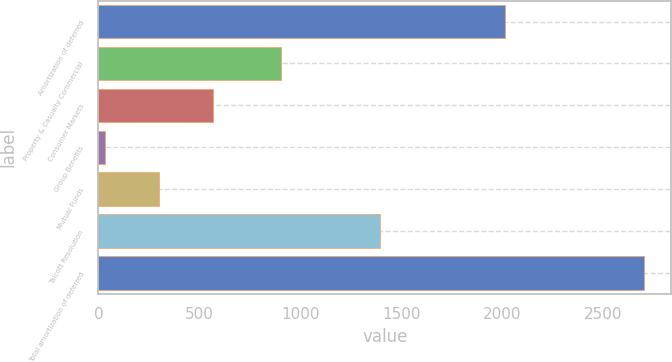Convert chart. <chart><loc_0><loc_0><loc_500><loc_500><bar_chart><fcel>Amortization of deferred<fcel>Property & Casualty Commercial<fcel>Consumer Markets<fcel>Group Benefits<fcel>Mutual Funds<fcel>Talcott Resolution<fcel>Total amortization of deferred<nl><fcel>2013<fcel>905<fcel>566.6<fcel>33<fcel>299.8<fcel>1392<fcel>2701<nl></chart> 